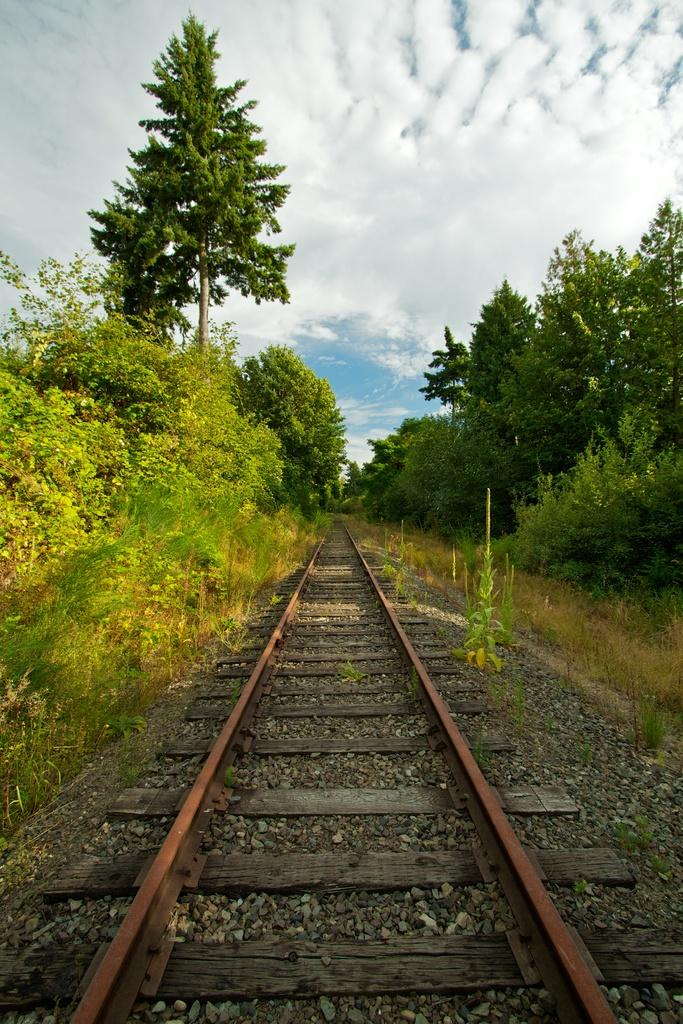What type of vegetation can be seen in the image? There are trees in the image. What type of transportation infrastructure is present in the image? There is a railway track in the image. What is the ground covered with in the image? There is grass in the image. What is visible in the sky in the image? The sky is visible in the image, and there are clouds in the sky. What type of precious metal can be seen in the image? There is no precious metal, such as gold or silver, present in the image. What type of things are visible in the image? This question is too vague and cannot be definitively answered based on the provided facts. The image contains trees, a railway track, grass, the sky, and clouds, but these are not "things" in the sense of the question. 